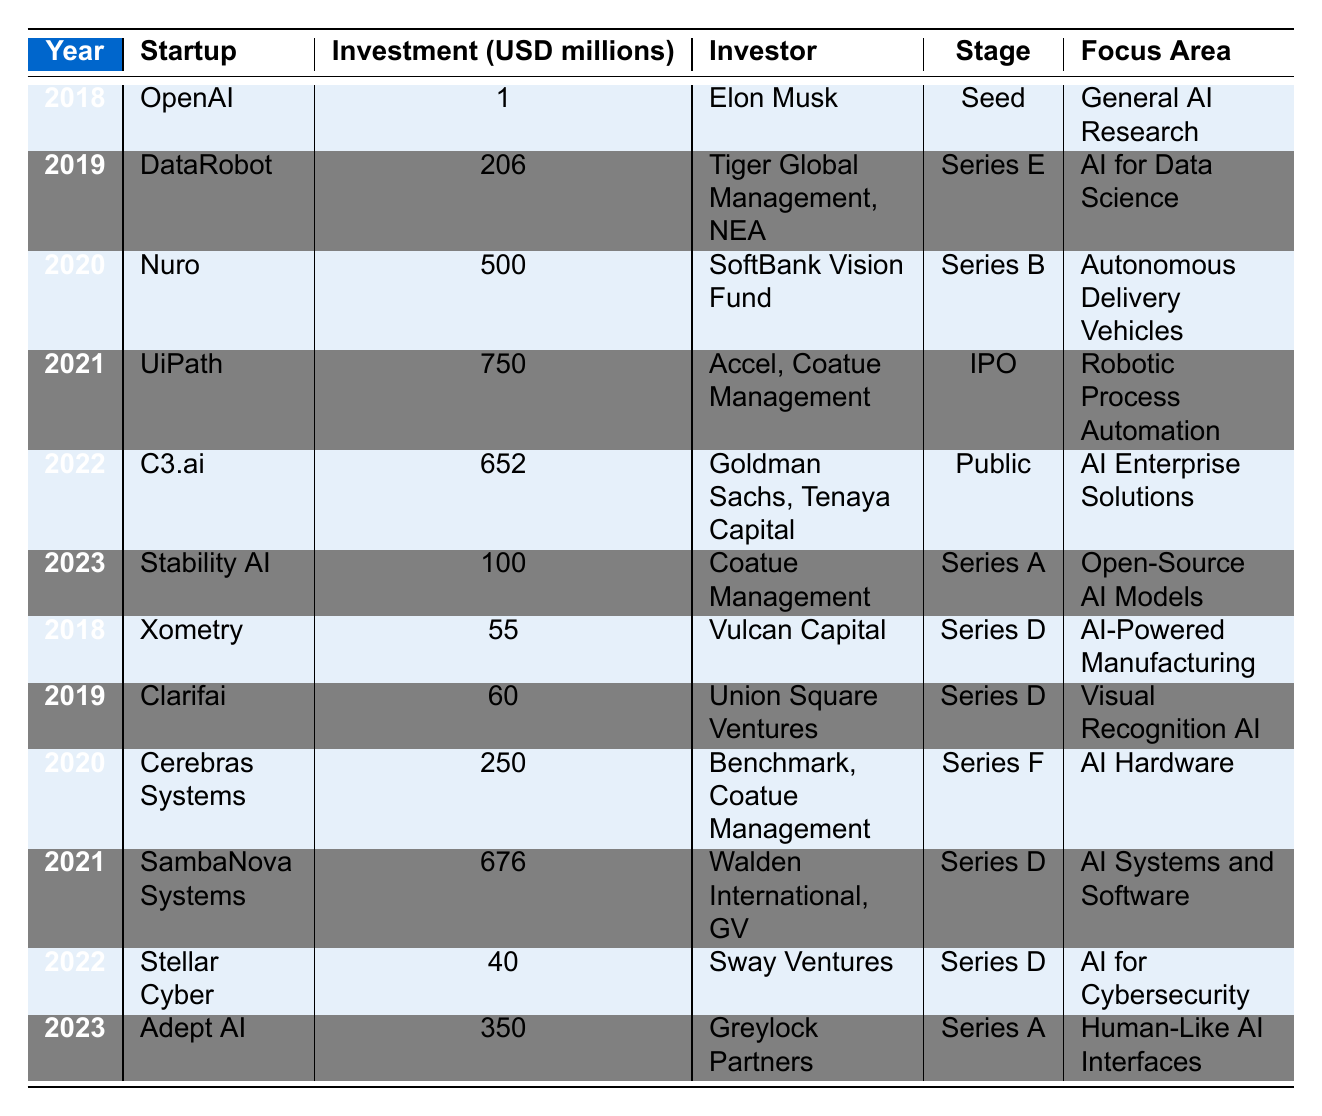What was the total investment in AI startups in 2021? To find the total investment in AI startups in 2021, sum the investments listed for that year: 750 (UiPath) + 676 (SambaNova Systems) = 1426 million USD.
Answer: 1426 million USD Which startup received the highest investment in 2020? Looking at the data for 2020, Nuro received an investment of 500 million USD, while Cerebras Systems received 250 million USD. So, Nuro is the startup with the highest investment that year.
Answer: Nuro Did any startups receive investments in 2019 less than 100 million USD? Check the investments for 2019: DataRobot received 206 million USD, and Clarifai received 60 million USD. Since 60 million is less than 100 million, the answer is yes.
Answer: Yes What is the average investment amount across all startups in 2022? In 2022, the investments were 652 million USD (C3.ai) and 40 million USD (Stellar Cyber). To find the average: (652 + 40) / 2 = 346 million USD.
Answer: 346 million USD Which investor invested in the most startups across the years shown in the table? Reviewing the investors, multiple startups received funding from different investors, but focusing on individual investors: Coatue Management invested in Stability AI and Adept AI, totaling 450 million USD. However, without counting each investor's total distinctly, the investor information alone doesn't clarify across the startups clearly without more data manipulation.
Answer: Not enough information In which year was the lowest investment in AI startups recorded and how much was it? The lowest investment recorded was in 2018 with OpenAI receiving 1 million USD. Thus, the year and investment amount is 2018 and 1 million USD.
Answer: 2018 and 1 million USD How much more investment did UiPath receive than C3.ai in 2021 and 2022? UiPath received 750 million USD in 2021, and C3.ai received 652 million USD in 2022. The difference is 750 - 652 = 98 million USD, so UiPath received 98 million USD more.
Answer: 98 million USD What percentage of the total investment in AI from 2018 to 2023 is attributed to Series A funding stages? The total for Series A (Stability AI, 100 million USD and Adept AI, 350 million USD) is 450 million USD, and the total investment from 2018 to 2023 is the sum of all listed investments equals 3,295 million USD. The percentage is (450 / 3295) * 100 = 13.65%.
Answer: 13.65% Which focus area had the biggest investment in 2021? For 2021, the focus areas are Robotic Process Automation and AI Systems and Software with investments of 750 million USD (UiPath) and 676 million USD (SambaNova Systems), respectively. Robotic Process Automation received the biggest investment.
Answer: Robotic Process Automation 